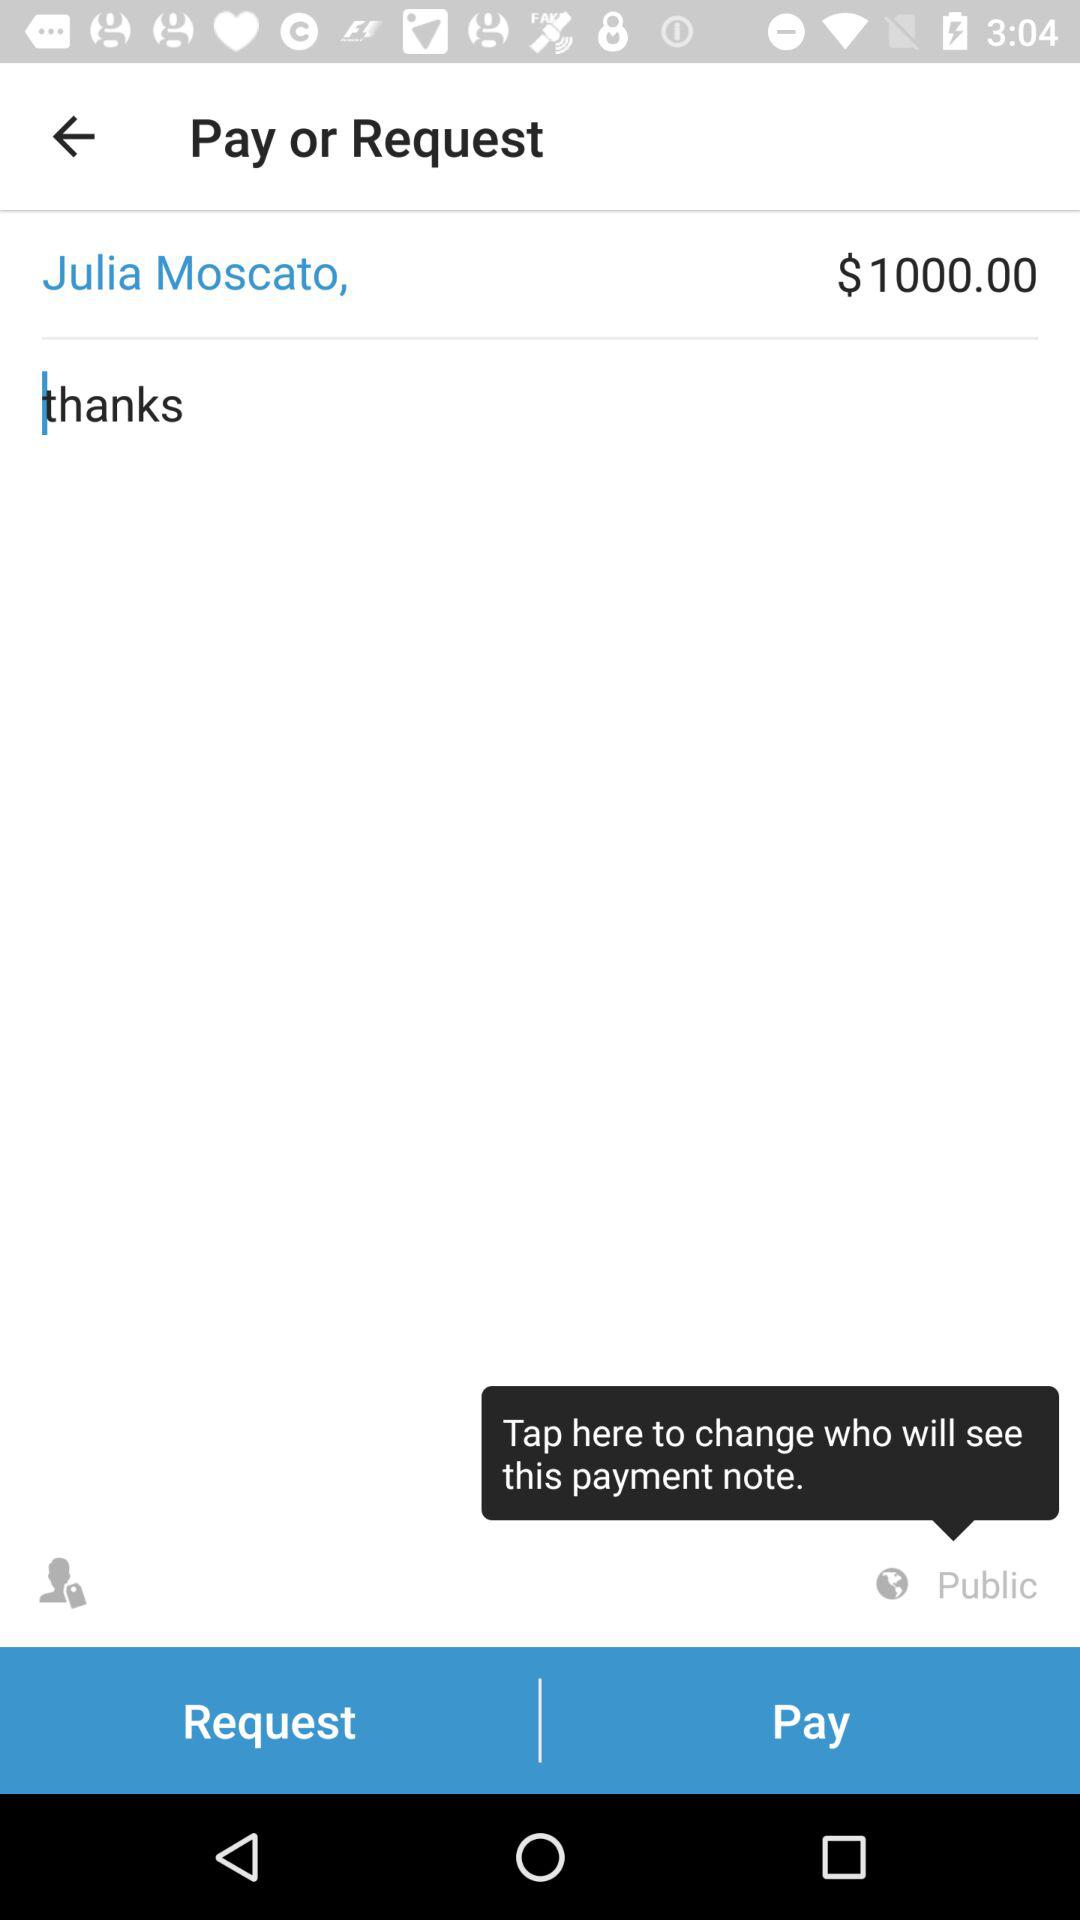What is the selected privacy for seeing the payment note? The selected privacy is "Public". 